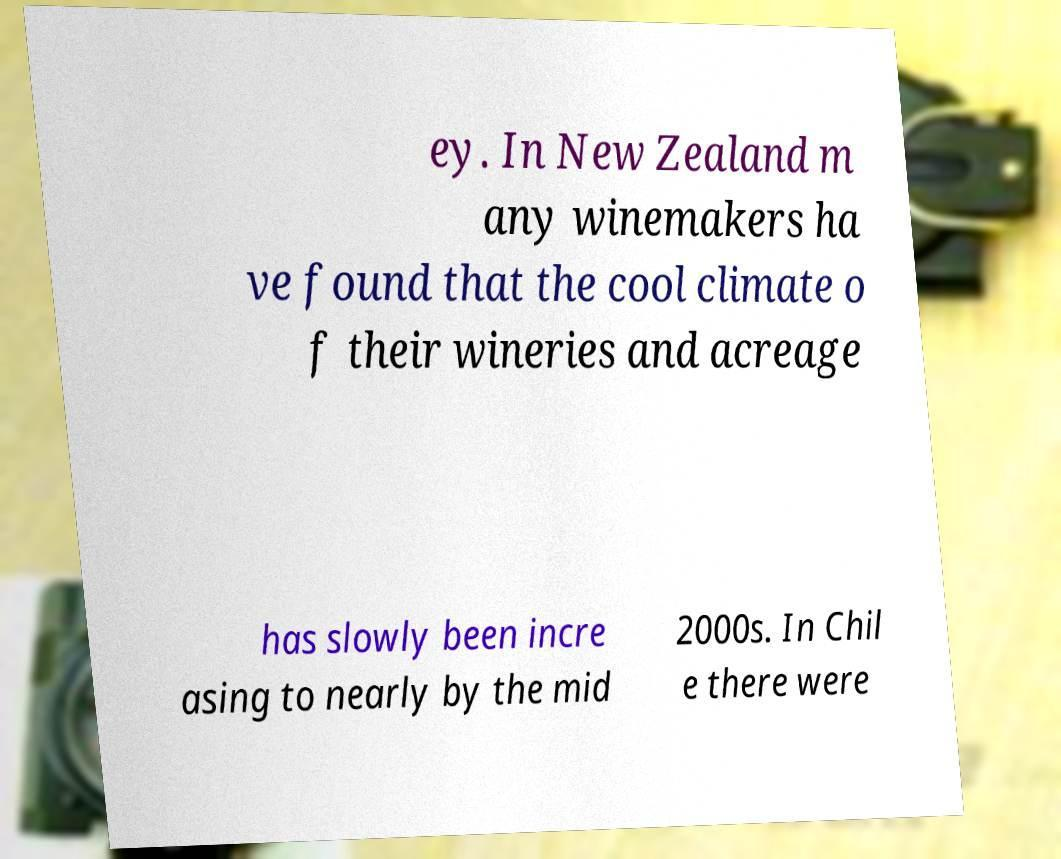Could you assist in decoding the text presented in this image and type it out clearly? ey. In New Zealand m any winemakers ha ve found that the cool climate o f their wineries and acreage has slowly been incre asing to nearly by the mid 2000s. In Chil e there were 